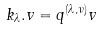Convert formula to latex. <formula><loc_0><loc_0><loc_500><loc_500>k _ { \lambda } . v = q ^ { ( \lambda , \nu ) } v</formula> 